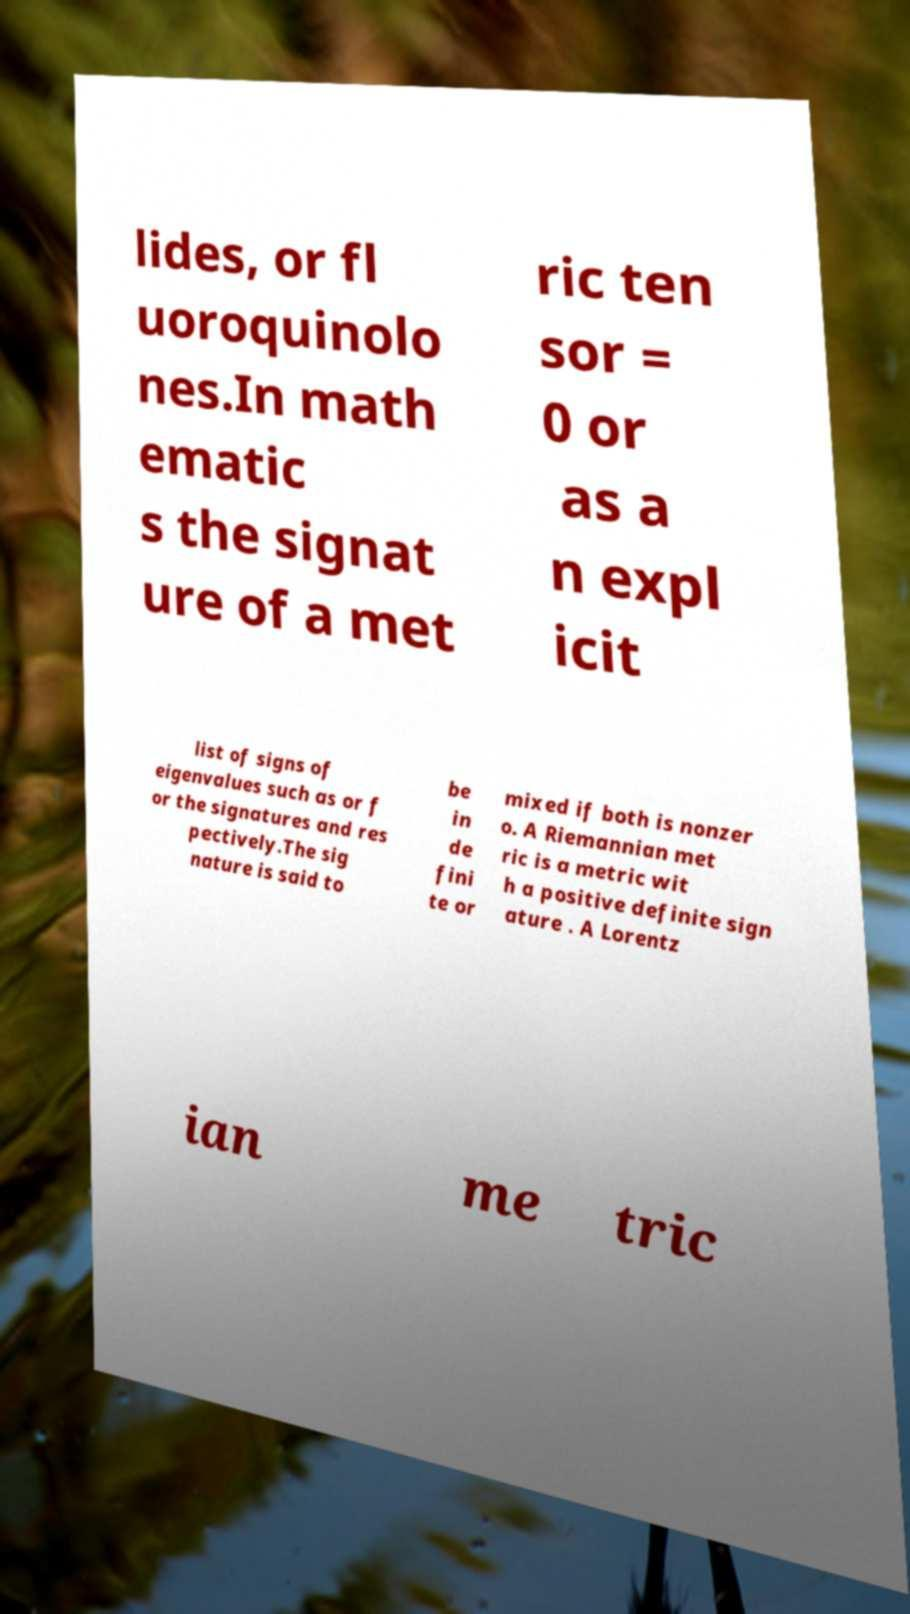I need the written content from this picture converted into text. Can you do that? lides, or fl uoroquinolo nes.In math ematic s the signat ure of a met ric ten sor = 0 or as a n expl icit list of signs of eigenvalues such as or f or the signatures and res pectively.The sig nature is said to be in de fini te or mixed if both is nonzer o. A Riemannian met ric is a metric wit h a positive definite sign ature . A Lorentz ian me tric 